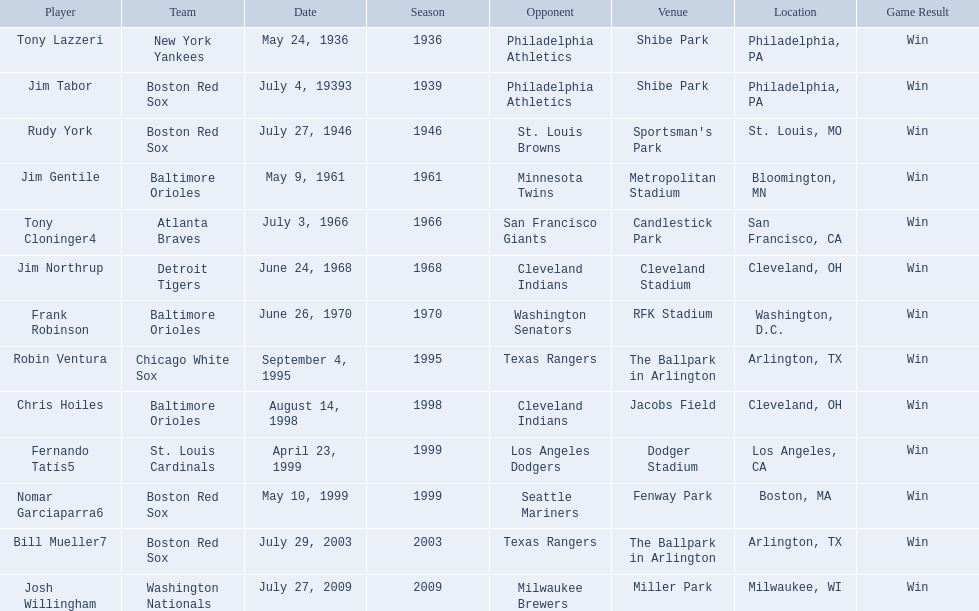Who were all the teams? New York Yankees, Boston Red Sox, Boston Red Sox, Baltimore Orioles, Atlanta Braves, Detroit Tigers, Baltimore Orioles, Chicago White Sox, Baltimore Orioles, St. Louis Cardinals, Boston Red Sox, Boston Red Sox, Washington Nationals. What about opponents? Philadelphia Athletics, Philadelphia Athletics, St. Louis Browns, Minnesota Twins, San Francisco Giants, Cleveland Indians, Washington Senators, Texas Rangers, Cleveland Indians, Los Angeles Dodgers, Seattle Mariners, Texas Rangers, Milwaukee Brewers. And when did they play? May 24, 1936, July 4, 19393, July 27, 1946, May 9, 1961, July 3, 1966, June 24, 1968, June 26, 1970, September 4, 1995, August 14, 1998, April 23, 1999, May 10, 1999, July 29, 2003, July 27, 2009. Which team played the red sox on july 27, 1946	? St. Louis Browns. 